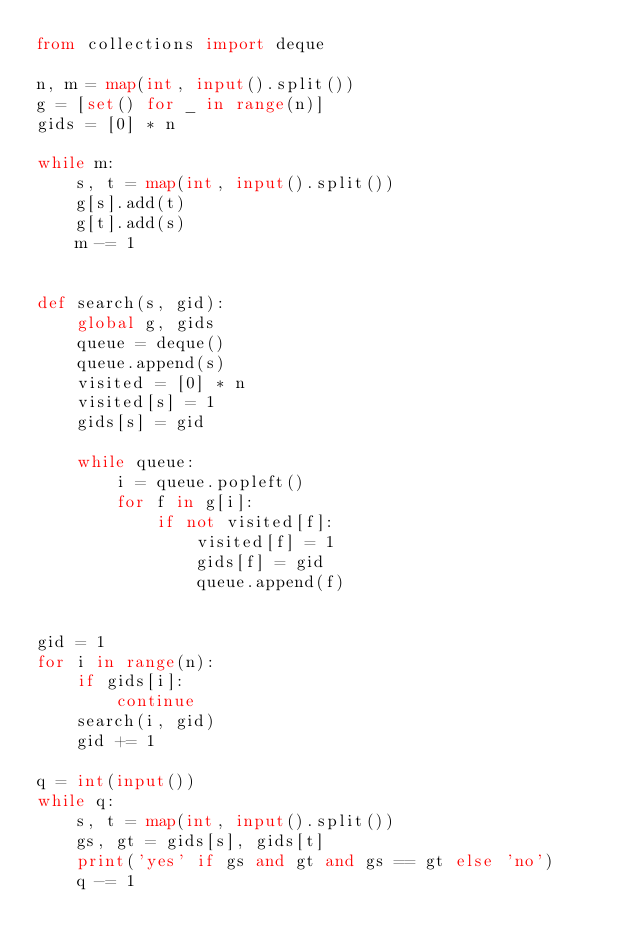<code> <loc_0><loc_0><loc_500><loc_500><_Python_>from collections import deque

n, m = map(int, input().split())
g = [set() for _ in range(n)]
gids = [0] * n

while m:
    s, t = map(int, input().split())
    g[s].add(t)
    g[t].add(s)
    m -= 1


def search(s, gid):
    global g, gids
    queue = deque()
    queue.append(s)
    visited = [0] * n
    visited[s] = 1
    gids[s] = gid

    while queue:
        i = queue.popleft()
        for f in g[i]:
            if not visited[f]:
                visited[f] = 1
                gids[f] = gid
                queue.append(f)


gid = 1
for i in range(n):
    if gids[i]:
        continue
    search(i, gid)
    gid += 1

q = int(input())
while q:
    s, t = map(int, input().split())
    gs, gt = gids[s], gids[t]
    print('yes' if gs and gt and gs == gt else 'no')
    q -= 1</code> 